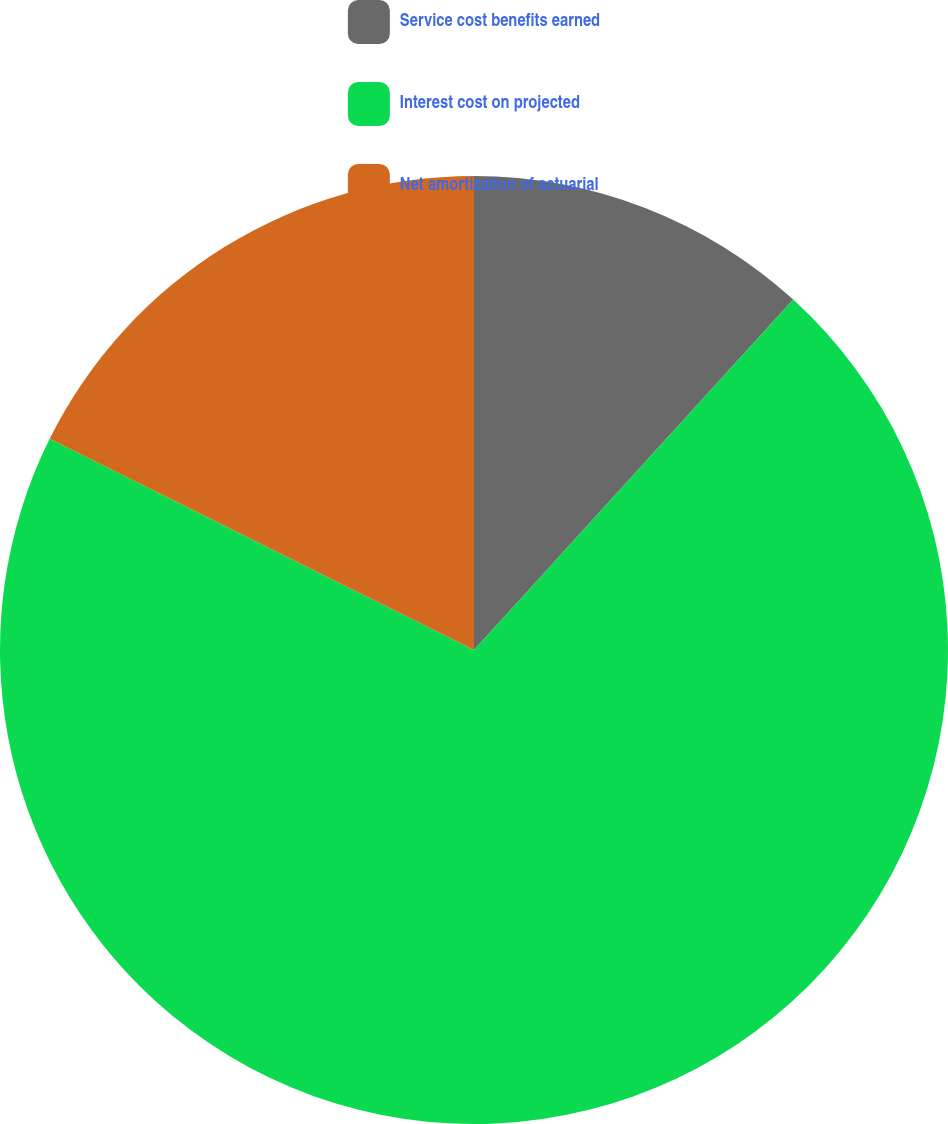Convert chart to OTSL. <chart><loc_0><loc_0><loc_500><loc_500><pie_chart><fcel>Service cost benefits earned<fcel>Interest cost on projected<fcel>Net amortization of actuarial<nl><fcel>11.76%<fcel>70.59%<fcel>17.65%<nl></chart> 